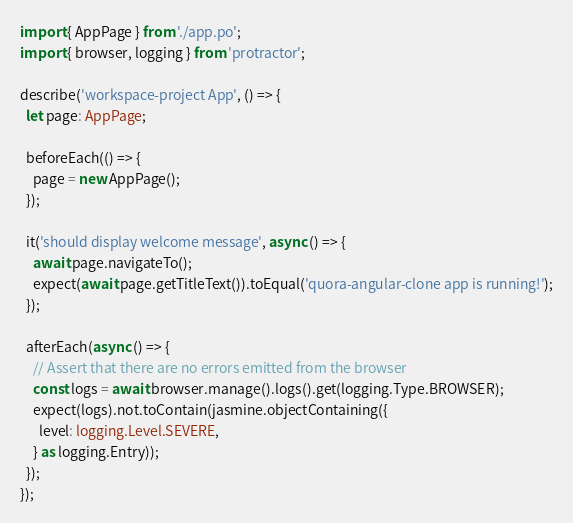Convert code to text. <code><loc_0><loc_0><loc_500><loc_500><_TypeScript_>import { AppPage } from './app.po';
import { browser, logging } from 'protractor';

describe('workspace-project App', () => {
  let page: AppPage;

  beforeEach(() => {
    page = new AppPage();
  });

  it('should display welcome message', async () => {
    await page.navigateTo();
    expect(await page.getTitleText()).toEqual('quora-angular-clone app is running!');
  });

  afterEach(async () => {
    // Assert that there are no errors emitted from the browser
    const logs = await browser.manage().logs().get(logging.Type.BROWSER);
    expect(logs).not.toContain(jasmine.objectContaining({
      level: logging.Level.SEVERE,
    } as logging.Entry));
  });
});
</code> 